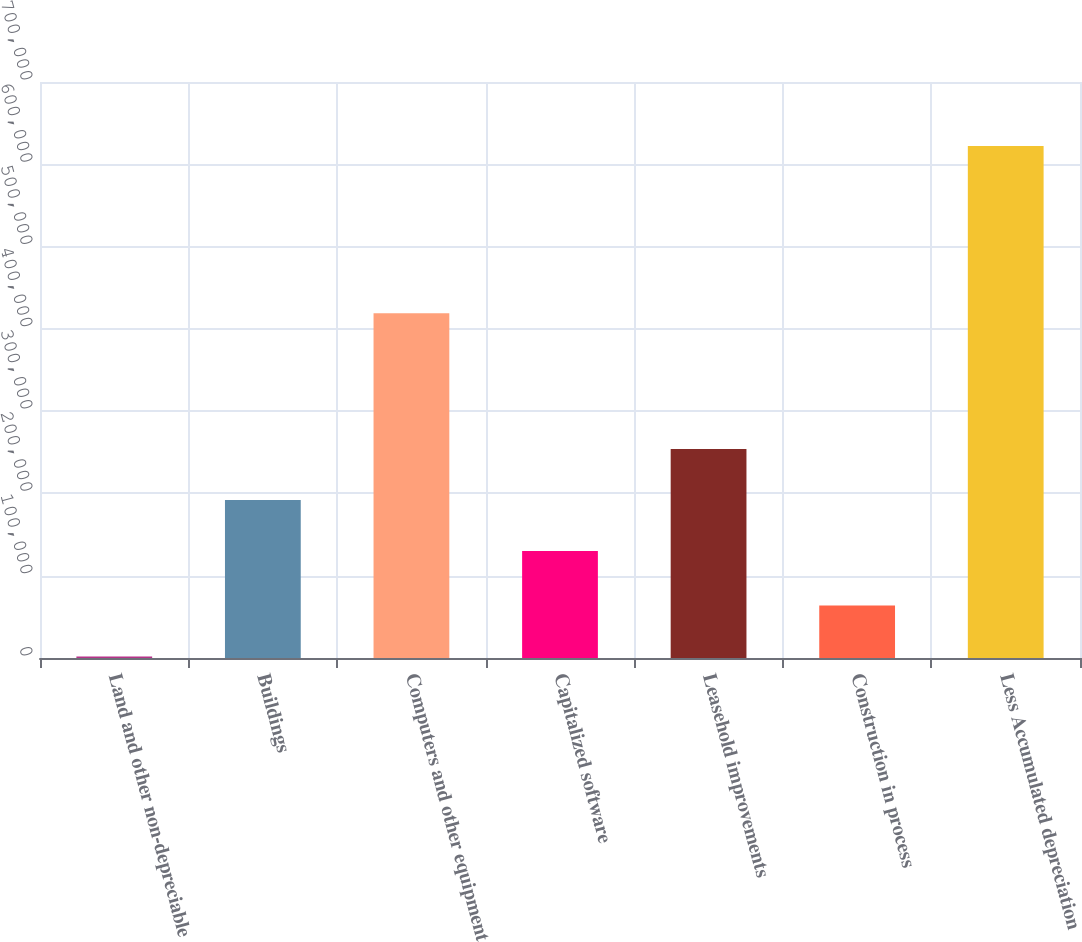Convert chart. <chart><loc_0><loc_0><loc_500><loc_500><bar_chart><fcel>Land and other non-depreciable<fcel>Buildings<fcel>Computers and other equipment<fcel>Capitalized software<fcel>Leasehold improvements<fcel>Construction in process<fcel>Less Accumulated depreciation<nl><fcel>1892<fcel>192069<fcel>419101<fcel>130027<fcel>254111<fcel>63934.1<fcel>622313<nl></chart> 